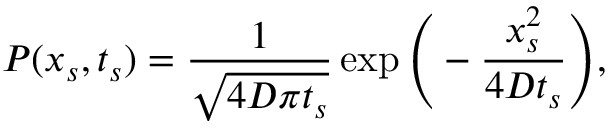Convert formula to latex. <formula><loc_0><loc_0><loc_500><loc_500>P ( x _ { s } , t _ { s } ) = \frac { 1 } { \sqrt { 4 D \pi t _ { s } } } \exp \left ( - \frac { x _ { s } ^ { 2 } } { 4 D t _ { s } } \right ) ,</formula> 